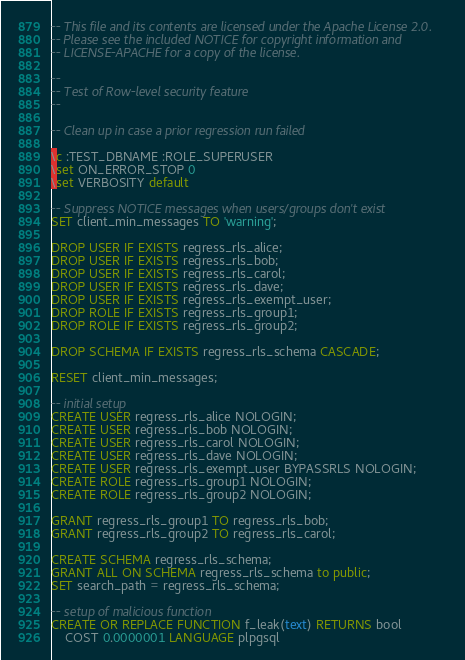<code> <loc_0><loc_0><loc_500><loc_500><_SQL_>-- This file and its contents are licensed under the Apache License 2.0.
-- Please see the included NOTICE for copyright information and
-- LICENSE-APACHE for a copy of the license.

--
-- Test of Row-level security feature
--

-- Clean up in case a prior regression run failed

\c :TEST_DBNAME :ROLE_SUPERUSER
\set ON_ERROR_STOP 0
\set VERBOSITY default

-- Suppress NOTICE messages when users/groups don't exist
SET client_min_messages TO 'warning';

DROP USER IF EXISTS regress_rls_alice;
DROP USER IF EXISTS regress_rls_bob;
DROP USER IF EXISTS regress_rls_carol;
DROP USER IF EXISTS regress_rls_dave;
DROP USER IF EXISTS regress_rls_exempt_user;
DROP ROLE IF EXISTS regress_rls_group1;
DROP ROLE IF EXISTS regress_rls_group2;

DROP SCHEMA IF EXISTS regress_rls_schema CASCADE;

RESET client_min_messages;

-- initial setup
CREATE USER regress_rls_alice NOLOGIN;
CREATE USER regress_rls_bob NOLOGIN;
CREATE USER regress_rls_carol NOLOGIN;
CREATE USER regress_rls_dave NOLOGIN;
CREATE USER regress_rls_exempt_user BYPASSRLS NOLOGIN;
CREATE ROLE regress_rls_group1 NOLOGIN;
CREATE ROLE regress_rls_group2 NOLOGIN;

GRANT regress_rls_group1 TO regress_rls_bob;
GRANT regress_rls_group2 TO regress_rls_carol;

CREATE SCHEMA regress_rls_schema;
GRANT ALL ON SCHEMA regress_rls_schema to public;
SET search_path = regress_rls_schema;

-- setup of malicious function
CREATE OR REPLACE FUNCTION f_leak(text) RETURNS bool
    COST 0.0000001 LANGUAGE plpgsql</code> 